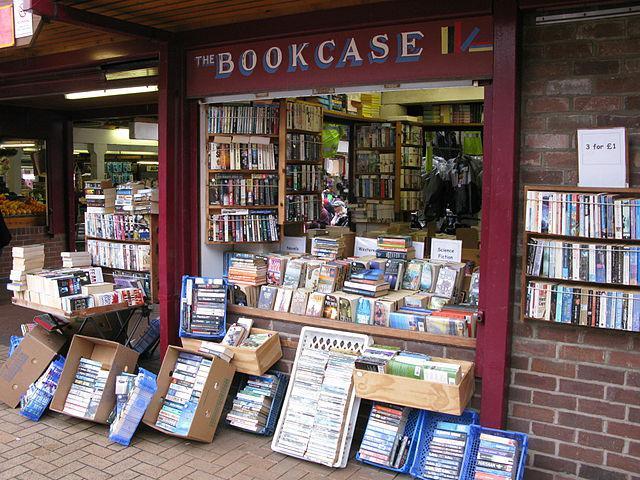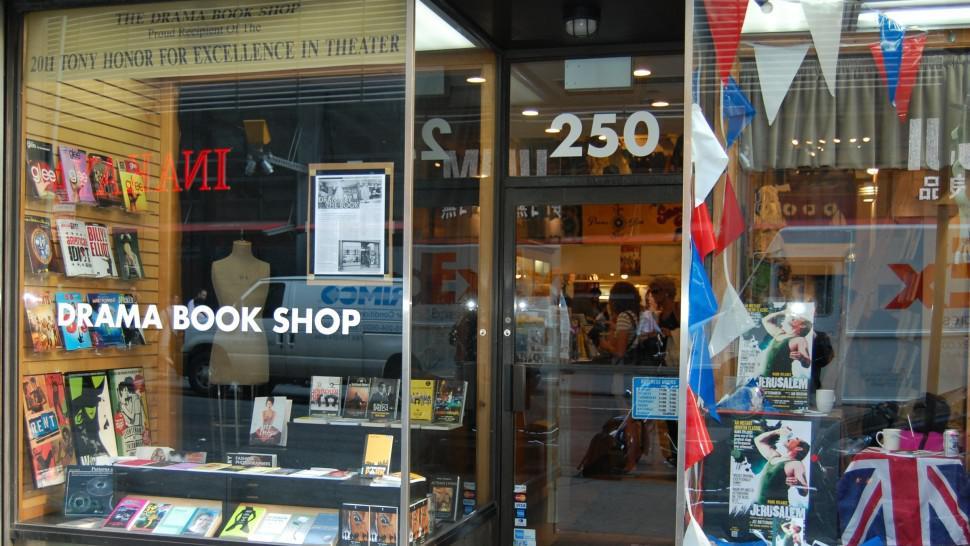The first image is the image on the left, the second image is the image on the right. Evaluate the accuracy of this statement regarding the images: "there are two people in the image on the left.". Is it true? Answer yes or no. No. The first image is the image on the left, the second image is the image on the right. Analyze the images presented: Is the assertion "One image is inside a bookshop and one image is outside a bookshop." valid? Answer yes or no. No. 